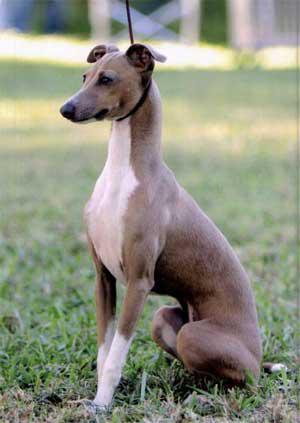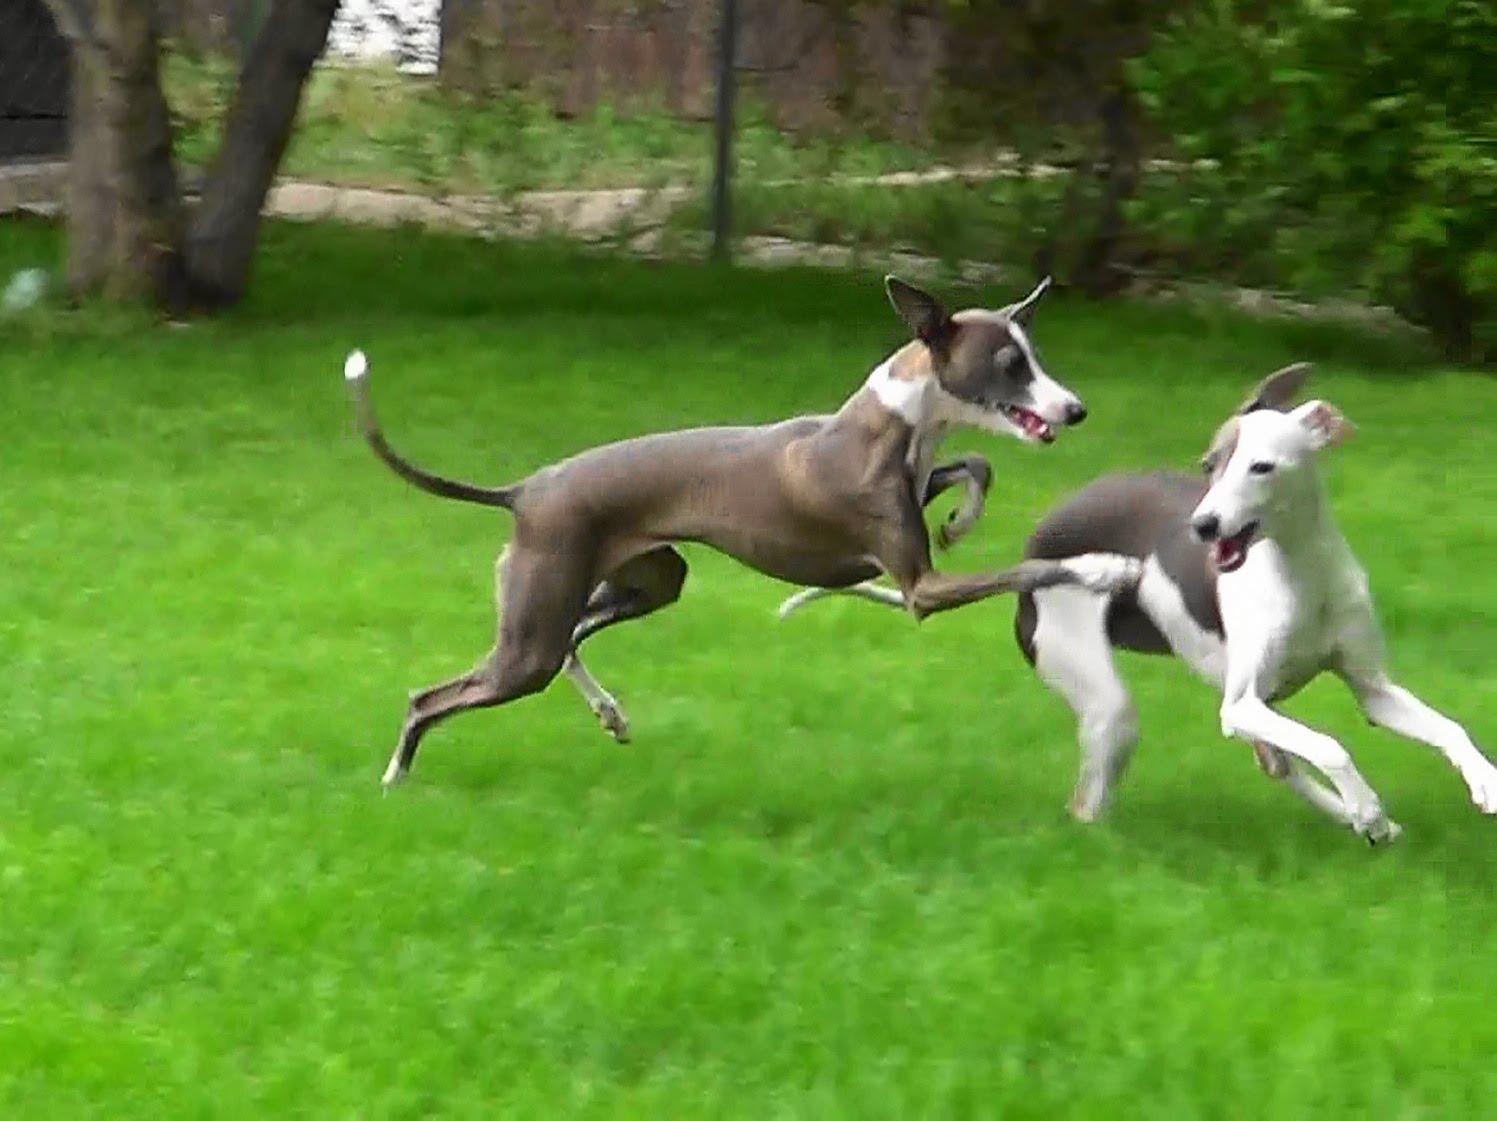The first image is the image on the left, the second image is the image on the right. Assess this claim about the two images: "The combined images include two dogs in motion, and no images show a human with a dog.". Correct or not? Answer yes or no. Yes. The first image is the image on the left, the second image is the image on the right. For the images shown, is this caption "There are at least three mammals in total." true? Answer yes or no. Yes. 